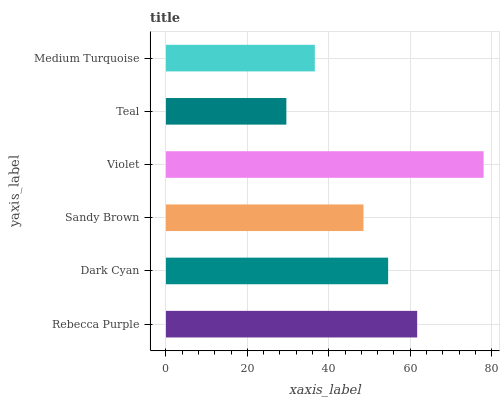Is Teal the minimum?
Answer yes or no. Yes. Is Violet the maximum?
Answer yes or no. Yes. Is Dark Cyan the minimum?
Answer yes or no. No. Is Dark Cyan the maximum?
Answer yes or no. No. Is Rebecca Purple greater than Dark Cyan?
Answer yes or no. Yes. Is Dark Cyan less than Rebecca Purple?
Answer yes or no. Yes. Is Dark Cyan greater than Rebecca Purple?
Answer yes or no. No. Is Rebecca Purple less than Dark Cyan?
Answer yes or no. No. Is Dark Cyan the high median?
Answer yes or no. Yes. Is Sandy Brown the low median?
Answer yes or no. Yes. Is Medium Turquoise the high median?
Answer yes or no. No. Is Dark Cyan the low median?
Answer yes or no. No. 